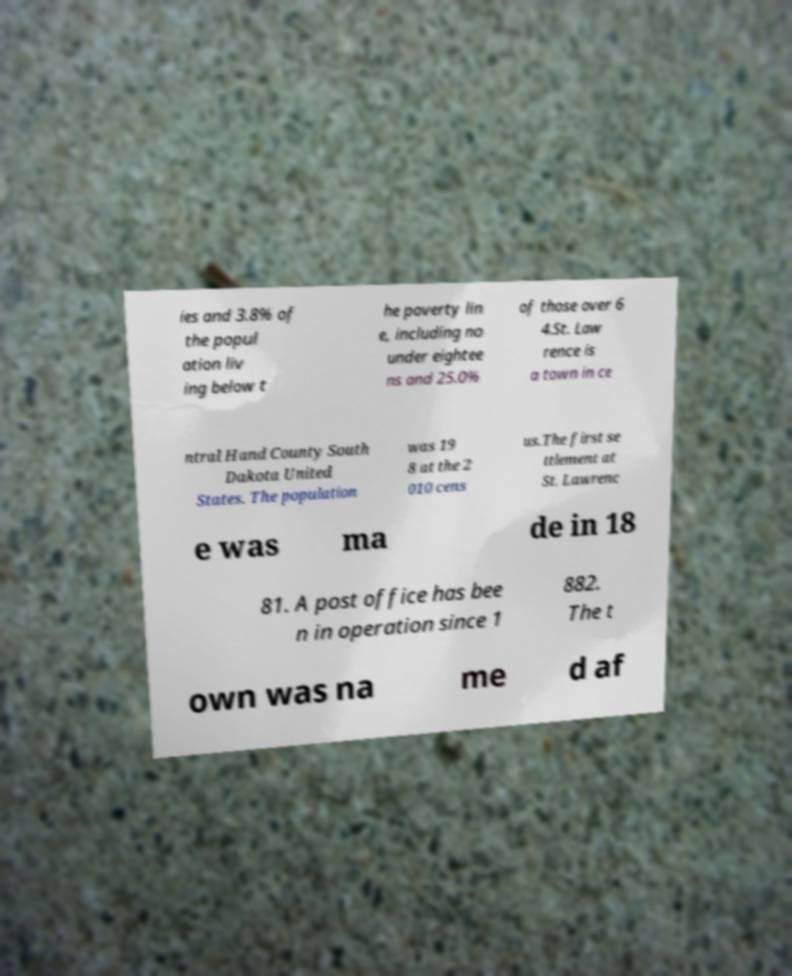What messages or text are displayed in this image? I need them in a readable, typed format. ies and 3.8% of the popul ation liv ing below t he poverty lin e, including no under eightee ns and 25.0% of those over 6 4.St. Law rence is a town in ce ntral Hand County South Dakota United States. The population was 19 8 at the 2 010 cens us.The first se ttlement at St. Lawrenc e was ma de in 18 81. A post office has bee n in operation since 1 882. The t own was na me d af 